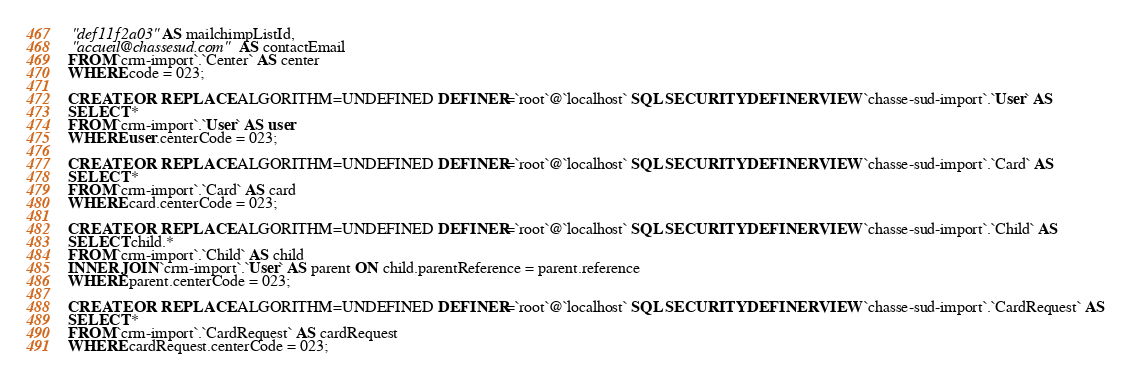<code> <loc_0><loc_0><loc_500><loc_500><_SQL_> "def11f2a03" AS mailchimpListId,
 "accueil@chassesud.com" AS contactEmail
FROM `crm-import`.`Center` AS center
WHERE code = 023;

CREATE OR REPLACE ALGORITHM=UNDEFINED DEFINER=`root`@`localhost` SQL SECURITY DEFINER VIEW `chasse-sud-import`.`User` AS
SELECT *
FROM `crm-import`.`User` AS user
WHERE user.centerCode = 023;

CREATE OR REPLACE ALGORITHM=UNDEFINED DEFINER=`root`@`localhost` SQL SECURITY DEFINER VIEW `chasse-sud-import`.`Card` AS
SELECT *
FROM `crm-import`.`Card` AS card
WHERE card.centerCode = 023;

CREATE OR REPLACE ALGORITHM=UNDEFINED DEFINER=`root`@`localhost` SQL SECURITY DEFINER VIEW `chasse-sud-import`.`Child` AS
SELECT child.*
FROM `crm-import`.`Child` AS child
INNER JOIN `crm-import`.`User` AS parent ON child.parentReference = parent.reference
WHERE parent.centerCode = 023;

CREATE OR REPLACE ALGORITHM=UNDEFINED DEFINER=`root`@`localhost` SQL SECURITY DEFINER VIEW `chasse-sud-import`.`CardRequest` AS
SELECT *
FROM `crm-import`.`CardRequest` AS cardRequest
WHERE cardRequest.centerCode = 023;
</code> 